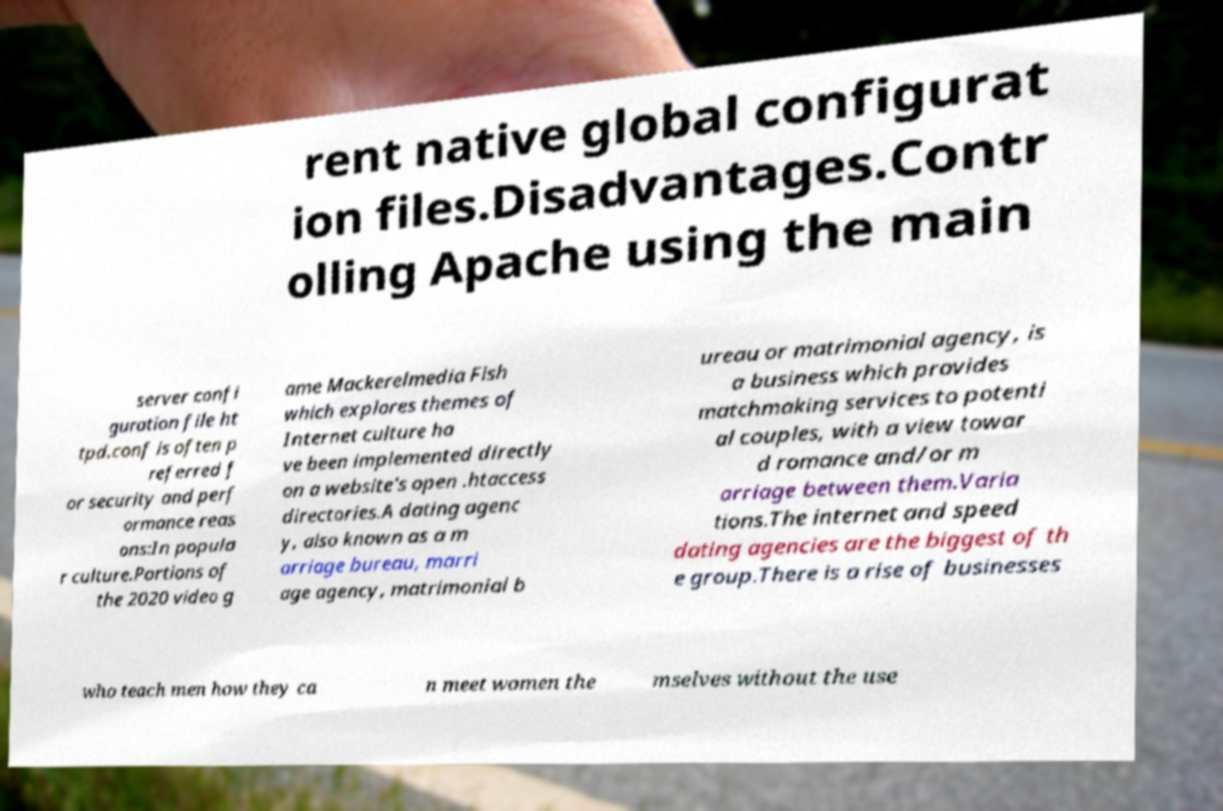There's text embedded in this image that I need extracted. Can you transcribe it verbatim? rent native global configurat ion files.Disadvantages.Contr olling Apache using the main server confi guration file ht tpd.conf is often p referred f or security and perf ormance reas ons:In popula r culture.Portions of the 2020 video g ame Mackerelmedia Fish which explores themes of Internet culture ha ve been implemented directly on a website's open .htaccess directories.A dating agenc y, also known as a m arriage bureau, marri age agency, matrimonial b ureau or matrimonial agency, is a business which provides matchmaking services to potenti al couples, with a view towar d romance and/or m arriage between them.Varia tions.The internet and speed dating agencies are the biggest of th e group.There is a rise of businesses who teach men how they ca n meet women the mselves without the use 